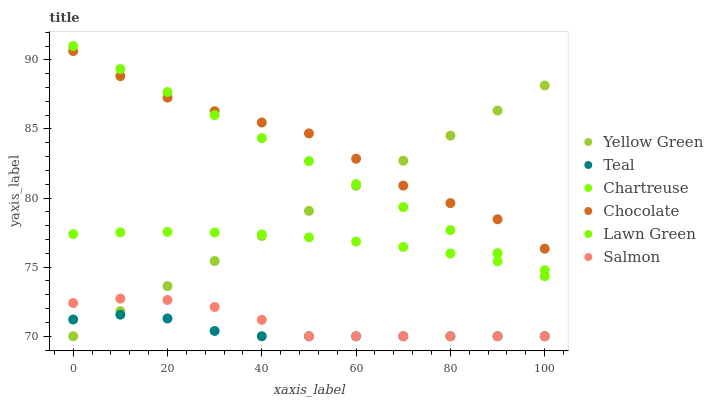Does Teal have the minimum area under the curve?
Answer yes or no. Yes. Does Chocolate have the maximum area under the curve?
Answer yes or no. Yes. Does Yellow Green have the minimum area under the curve?
Answer yes or no. No. Does Yellow Green have the maximum area under the curve?
Answer yes or no. No. Is Yellow Green the smoothest?
Answer yes or no. Yes. Is Chocolate the roughest?
Answer yes or no. Yes. Is Salmon the smoothest?
Answer yes or no. No. Is Salmon the roughest?
Answer yes or no. No. Does Yellow Green have the lowest value?
Answer yes or no. Yes. Does Chocolate have the lowest value?
Answer yes or no. No. Does Lawn Green have the highest value?
Answer yes or no. Yes. Does Yellow Green have the highest value?
Answer yes or no. No. Is Chartreuse less than Chocolate?
Answer yes or no. Yes. Is Chocolate greater than Teal?
Answer yes or no. Yes. Does Yellow Green intersect Chartreuse?
Answer yes or no. Yes. Is Yellow Green less than Chartreuse?
Answer yes or no. No. Is Yellow Green greater than Chartreuse?
Answer yes or no. No. Does Chartreuse intersect Chocolate?
Answer yes or no. No. 